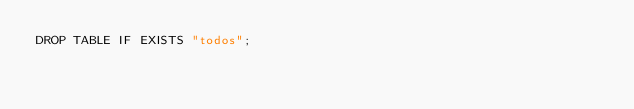Convert code to text. <code><loc_0><loc_0><loc_500><loc_500><_SQL_>DROP TABLE IF EXISTS "todos";
</code> 